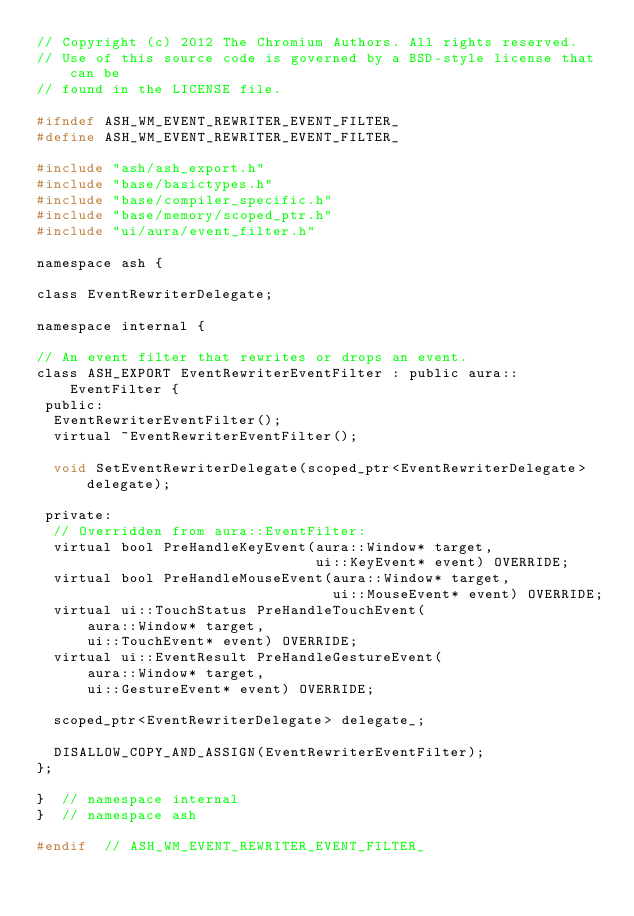Convert code to text. <code><loc_0><loc_0><loc_500><loc_500><_C_>// Copyright (c) 2012 The Chromium Authors. All rights reserved.
// Use of this source code is governed by a BSD-style license that can be
// found in the LICENSE file.

#ifndef ASH_WM_EVENT_REWRITER_EVENT_FILTER_
#define ASH_WM_EVENT_REWRITER_EVENT_FILTER_

#include "ash/ash_export.h"
#include "base/basictypes.h"
#include "base/compiler_specific.h"
#include "base/memory/scoped_ptr.h"
#include "ui/aura/event_filter.h"

namespace ash {

class EventRewriterDelegate;

namespace internal {

// An event filter that rewrites or drops an event.
class ASH_EXPORT EventRewriterEventFilter : public aura::EventFilter {
 public:
  EventRewriterEventFilter();
  virtual ~EventRewriterEventFilter();

  void SetEventRewriterDelegate(scoped_ptr<EventRewriterDelegate> delegate);

 private:
  // Overridden from aura::EventFilter:
  virtual bool PreHandleKeyEvent(aura::Window* target,
                                 ui::KeyEvent* event) OVERRIDE;
  virtual bool PreHandleMouseEvent(aura::Window* target,
                                   ui::MouseEvent* event) OVERRIDE;
  virtual ui::TouchStatus PreHandleTouchEvent(
      aura::Window* target,
      ui::TouchEvent* event) OVERRIDE;
  virtual ui::EventResult PreHandleGestureEvent(
      aura::Window* target,
      ui::GestureEvent* event) OVERRIDE;

  scoped_ptr<EventRewriterDelegate> delegate_;

  DISALLOW_COPY_AND_ASSIGN(EventRewriterEventFilter);
};

}  // namespace internal
}  // namespace ash

#endif  // ASH_WM_EVENT_REWRITER_EVENT_FILTER_
</code> 